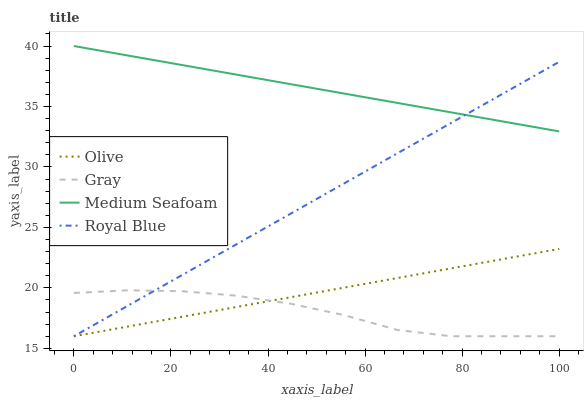Does Gray have the minimum area under the curve?
Answer yes or no. Yes. Does Medium Seafoam have the maximum area under the curve?
Answer yes or no. Yes. Does Medium Seafoam have the minimum area under the curve?
Answer yes or no. No. Does Gray have the maximum area under the curve?
Answer yes or no. No. Is Olive the smoothest?
Answer yes or no. Yes. Is Gray the roughest?
Answer yes or no. Yes. Is Medium Seafoam the smoothest?
Answer yes or no. No. Is Medium Seafoam the roughest?
Answer yes or no. No. Does Medium Seafoam have the lowest value?
Answer yes or no. No. Does Gray have the highest value?
Answer yes or no. No. Is Gray less than Medium Seafoam?
Answer yes or no. Yes. Is Medium Seafoam greater than Olive?
Answer yes or no. Yes. Does Gray intersect Medium Seafoam?
Answer yes or no. No. 